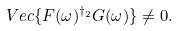Convert formula to latex. <formula><loc_0><loc_0><loc_500><loc_500>V e c \{ F ( \omega ) ^ { \dag _ { 2 } } G ( \omega ) \} \neq 0 .</formula> 